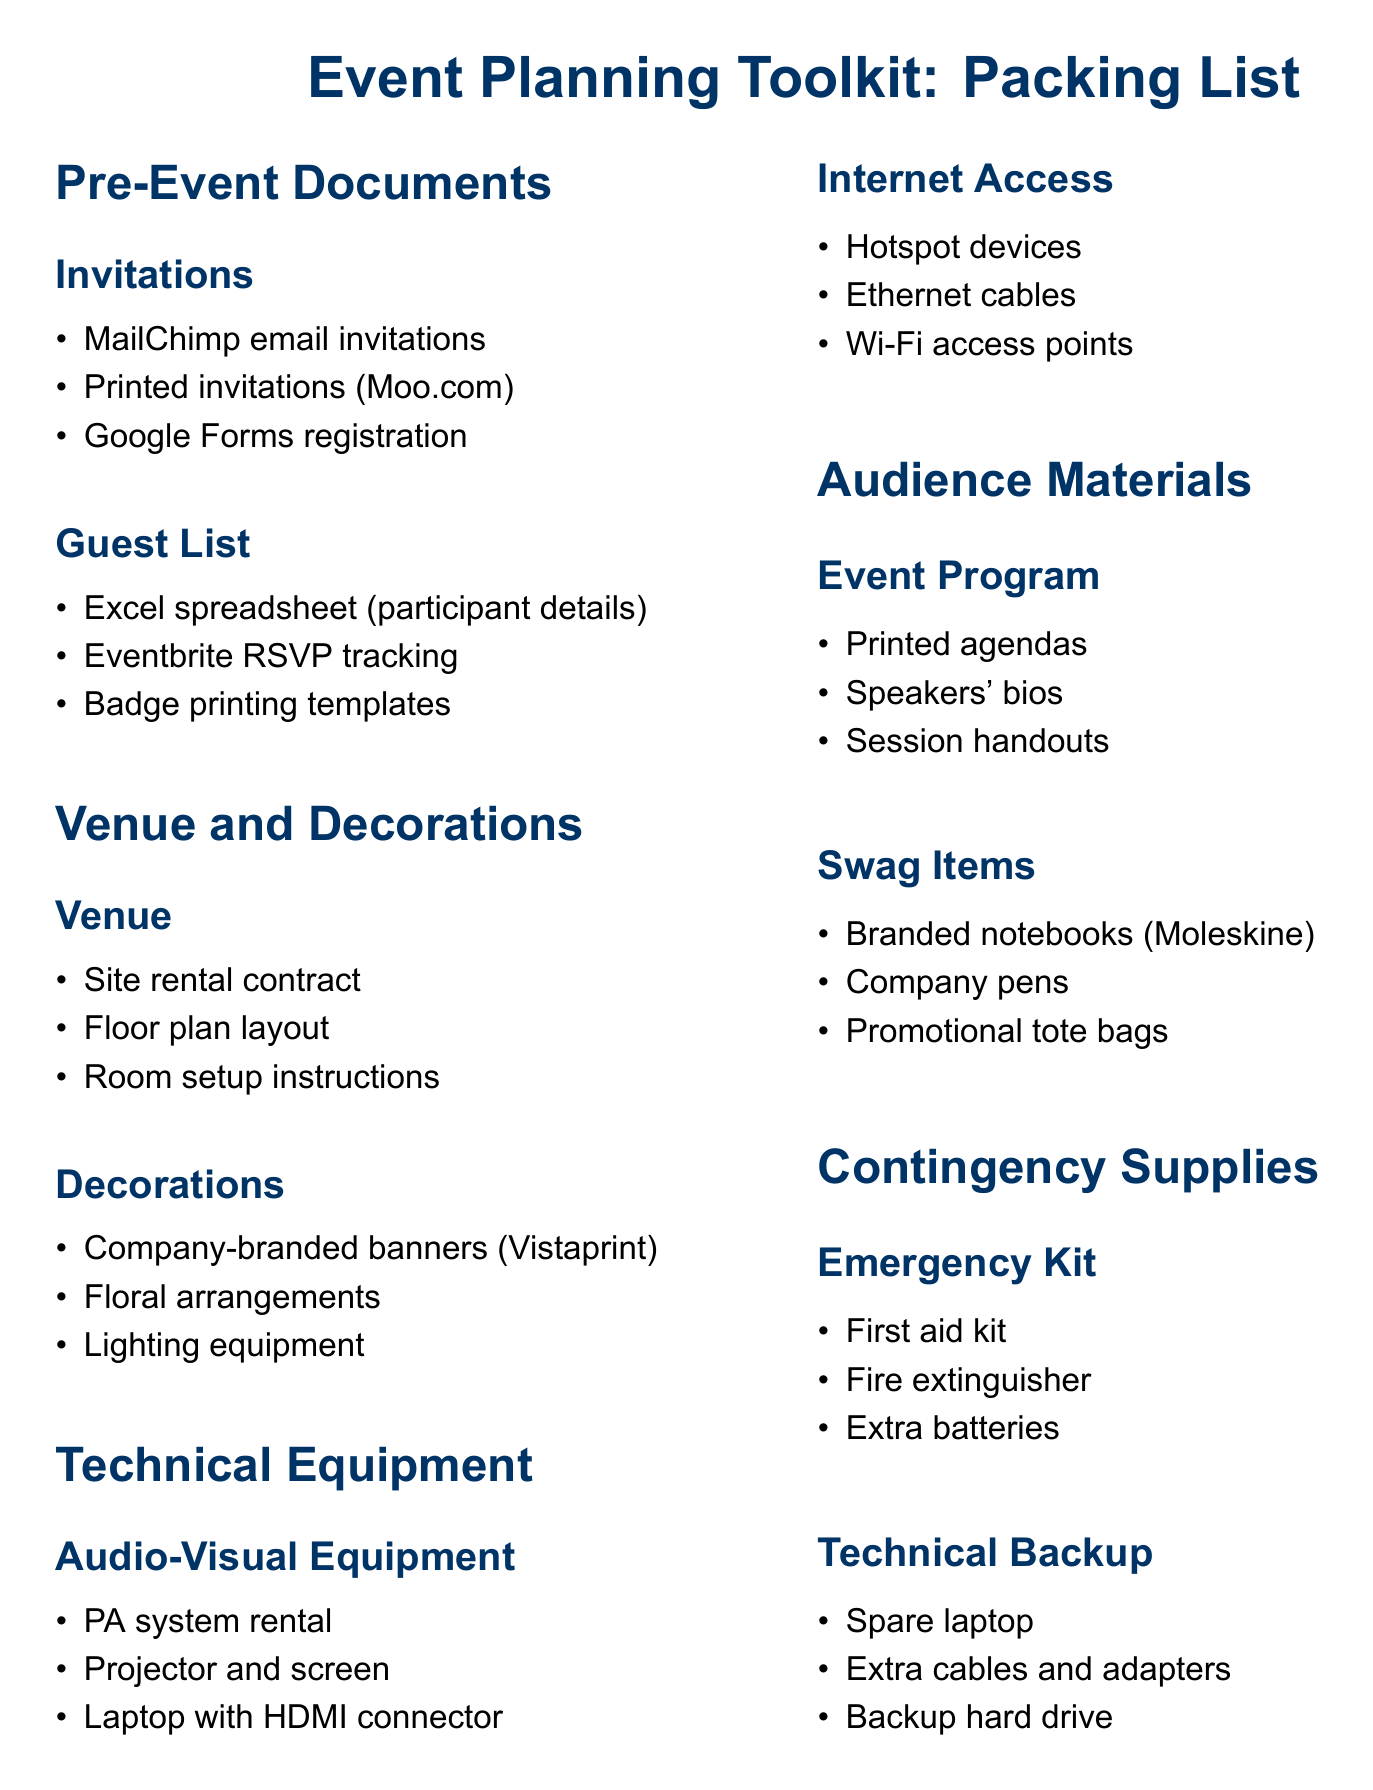What are the three methods for sending invitations? The document lists three items under Invitations: MailChimp email invitations, printed invitations, and Google Forms registration.
Answer: MailChimp email invitations, printed invitations, Google Forms registration How is the guest list being tracked? The document mentions two methods for tracking the guest list: an Excel spreadsheet and Eventbrite RSVP tracking.
Answer: Excel spreadsheet, Eventbrite RSVP tracking What type of kit is included for emergencies? The document specifies an emergency kit under Contingency Supplies which includes a first aid kit.
Answer: First aid kit How many swag items are listed? The document lists three swag items: branded notebooks, company pens, and promotional tote bags.
Answer: Three What item is required for audio-visual equipment? The document mentions that a PA system rental is needed under Audio-Visual Equipment.
Answer: PA system rental What is provided for technical backup? The document lists three items for technical backup: a spare laptop, extra cables and adapters, and a backup hard drive.
Answer: Spare laptop, extra cables and adapters, backup hard drive Which service is needed for internet access? The document includes hotspot devices under Internet Access as needed for internet connection.
Answer: Hotspot devices What item is listed under decorations? The document lists company-branded banners as one of the decoration items.
Answer: Company-branded banners How many contingency supplies categories are there? The document includes two categories under Contingency Supplies: Emergency Kit and Technical Backup.
Answer: Two 